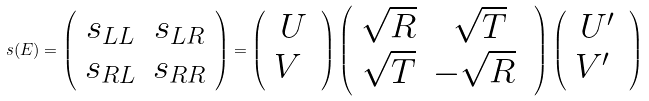Convert formula to latex. <formula><loc_0><loc_0><loc_500><loc_500>s ( E ) = \left ( \begin{array} { c c } s _ { L L } & s _ { L R } \\ s _ { R L } & s _ { R R } \end{array} \right ) = \left ( \begin{array} { c } U \\ V \ \end{array} \right ) \left ( \begin{array} { c c } \sqrt { R } & \sqrt { T } \\ \sqrt { T } & - \sqrt { R } \ \end{array} \right ) \left ( \begin{array} { c } U ^ { \prime } \\ V ^ { \prime } \ \end{array} \right )</formula> 